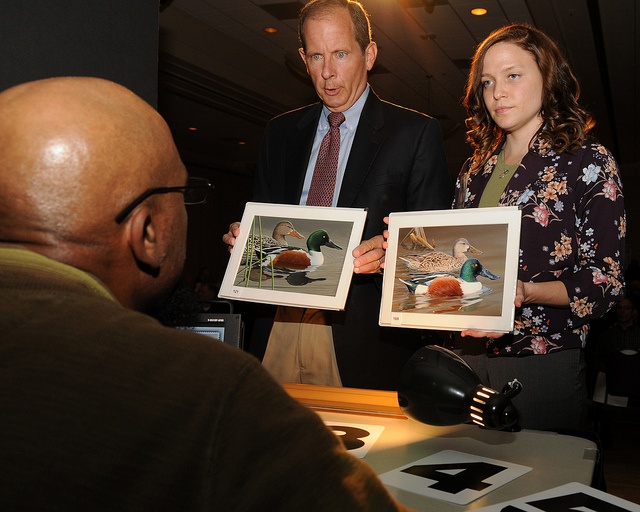Describe the objects in this image and their specific colors. I can see people in black, maroon, brown, and tan tones, people in black, gray, maroon, and tan tones, people in black, brown, and maroon tones, bird in black, gray, beige, and brown tones, and tie in black, maroon, and brown tones in this image. 